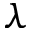<formula> <loc_0><loc_0><loc_500><loc_500>\lambda</formula> 